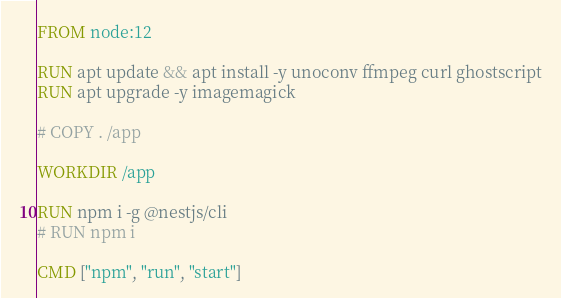<code> <loc_0><loc_0><loc_500><loc_500><_Dockerfile_>FROM node:12

RUN apt update && apt install -y unoconv ffmpeg curl ghostscript
RUN apt upgrade -y imagemagick

# COPY . /app

WORKDIR /app

RUN npm i -g @nestjs/cli
# RUN npm i

CMD ["npm", "run", "start"]
</code> 